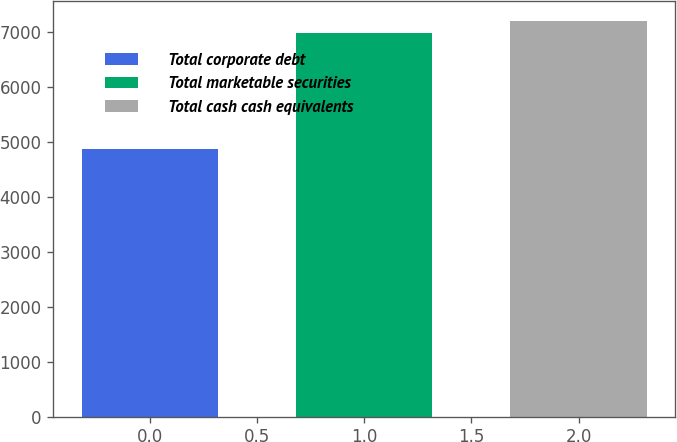<chart> <loc_0><loc_0><loc_500><loc_500><bar_chart><fcel>Total corporate debt<fcel>Total marketable securities<fcel>Total cash cash equivalents<nl><fcel>4881<fcel>6993<fcel>7204.2<nl></chart> 